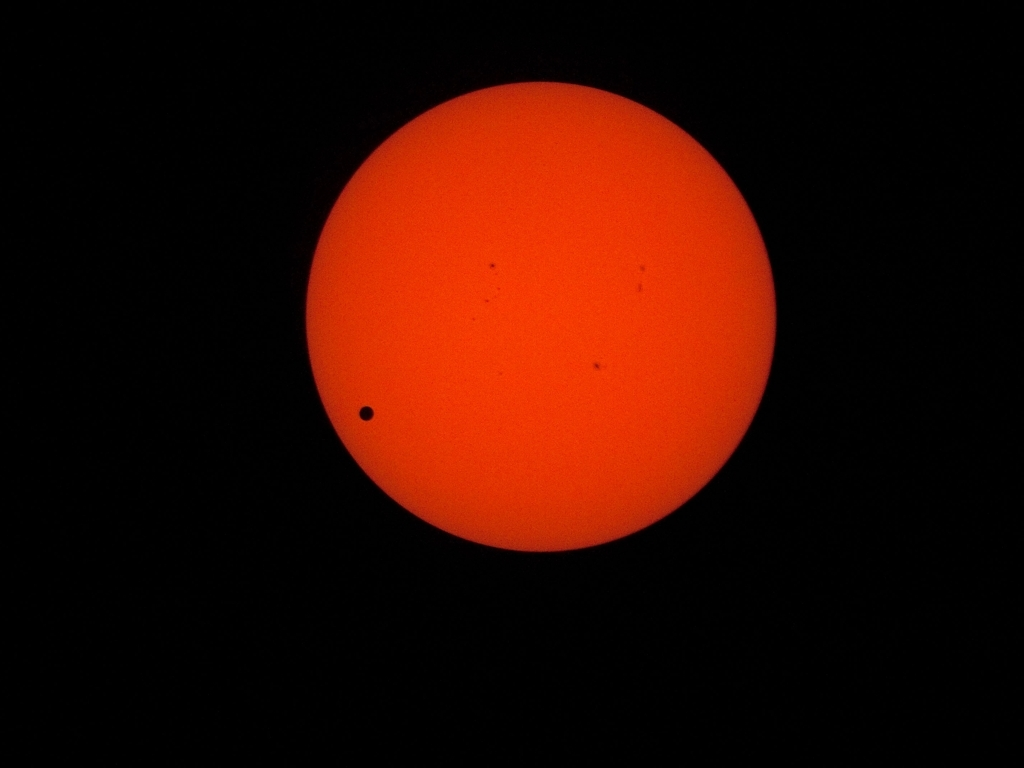Can you tell me what celestial event is being depicted in this image? This image appears to capture a transit event, where a smaller celestial body, such as a planet, passes between the sun and the Earth. The silhouetted round object against the bright backdrop of the sun suggests this is likely a transit of Mercury or Venus, as these are the only two planets in our solar system which can be observed from Earth as they cross the face of the sun. 